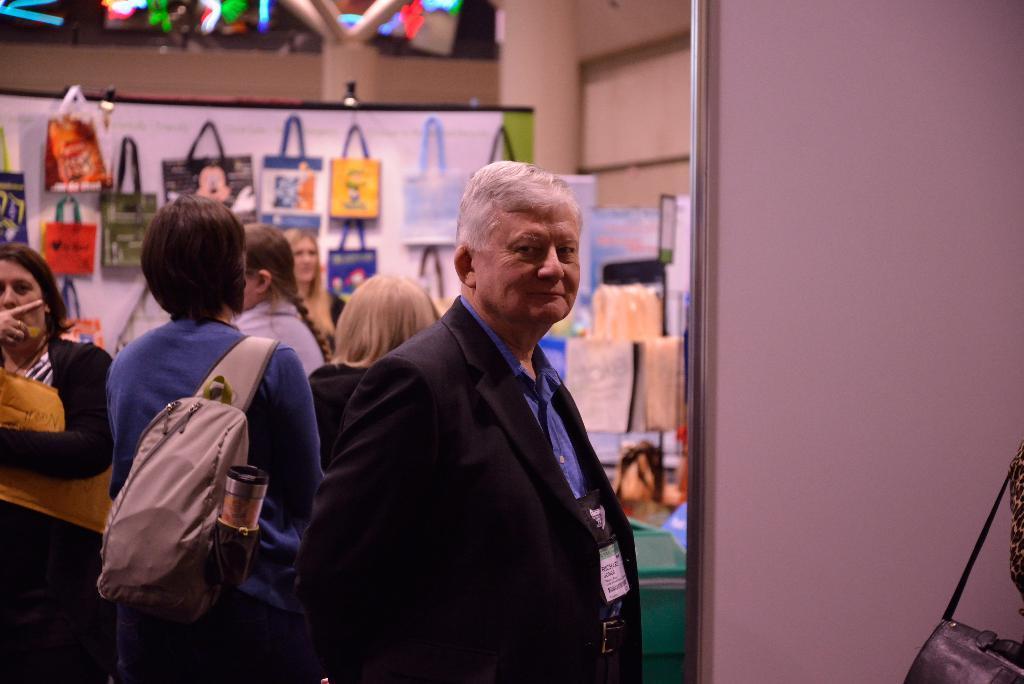In one or two sentences, can you explain what this image depicts? In this picture we can see a store. We can see bags, lights and few objects. On the right side of the picture we can see a man standing and smiling. We can see the partial part of a bag. 